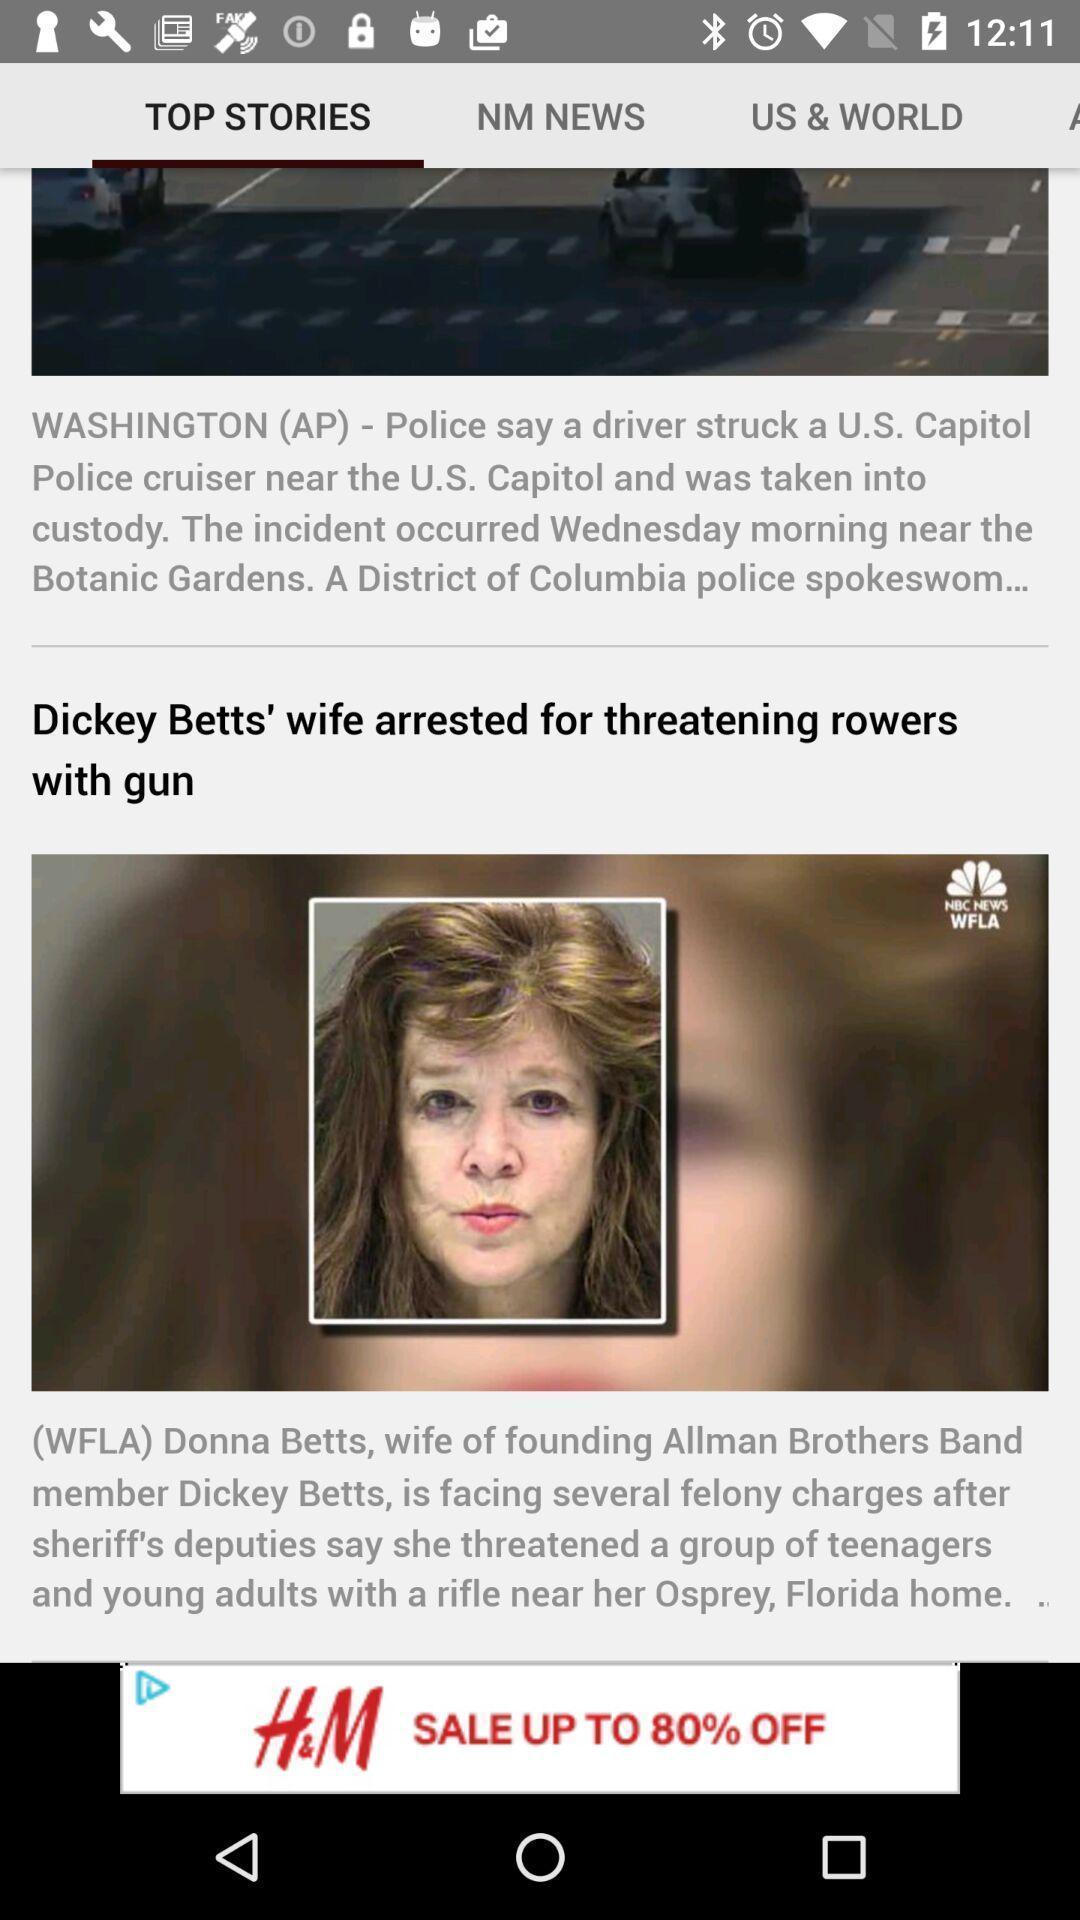Provide a description of this screenshot. Page showing latest breaking news. 